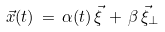Convert formula to latex. <formula><loc_0><loc_0><loc_500><loc_500>\vec { x } ( t ) \, = \, \alpha ( t ) \, \vec { \xi } \, + \, \beta \, \vec { \xi } _ { \perp }</formula> 